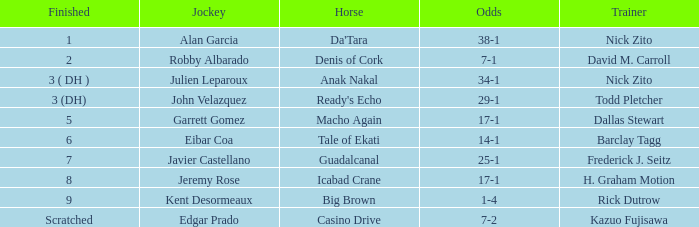What are the Odds for Trainer Barclay Tagg? 14-1. 